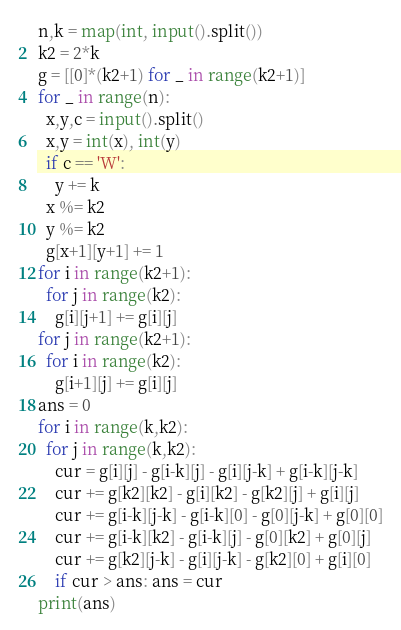<code> <loc_0><loc_0><loc_500><loc_500><_Python_>n,k = map(int, input().split())
k2 = 2*k
g = [[0]*(k2+1) for _ in range(k2+1)]
for _ in range(n):
  x,y,c = input().split()
  x,y = int(x), int(y)
  if c == 'W':
    y += k
  x %= k2
  y %= k2
  g[x+1][y+1] += 1
for i in range(k2+1):
  for j in range(k2):
    g[i][j+1] += g[i][j]
for j in range(k2+1):
  for i in range(k2):
    g[i+1][j] += g[i][j]
ans = 0
for i in range(k,k2):
  for j in range(k,k2):
    cur = g[i][j] - g[i-k][j] - g[i][j-k] + g[i-k][j-k]
    cur += g[k2][k2] - g[i][k2] - g[k2][j] + g[i][j]
    cur += g[i-k][j-k] - g[i-k][0] - g[0][j-k] + g[0][0]
    cur += g[i-k][k2] - g[i-k][j] - g[0][k2] + g[0][j]
    cur += g[k2][j-k] - g[i][j-k] - g[k2][0] + g[i][0]
    if cur > ans: ans = cur
print(ans)</code> 